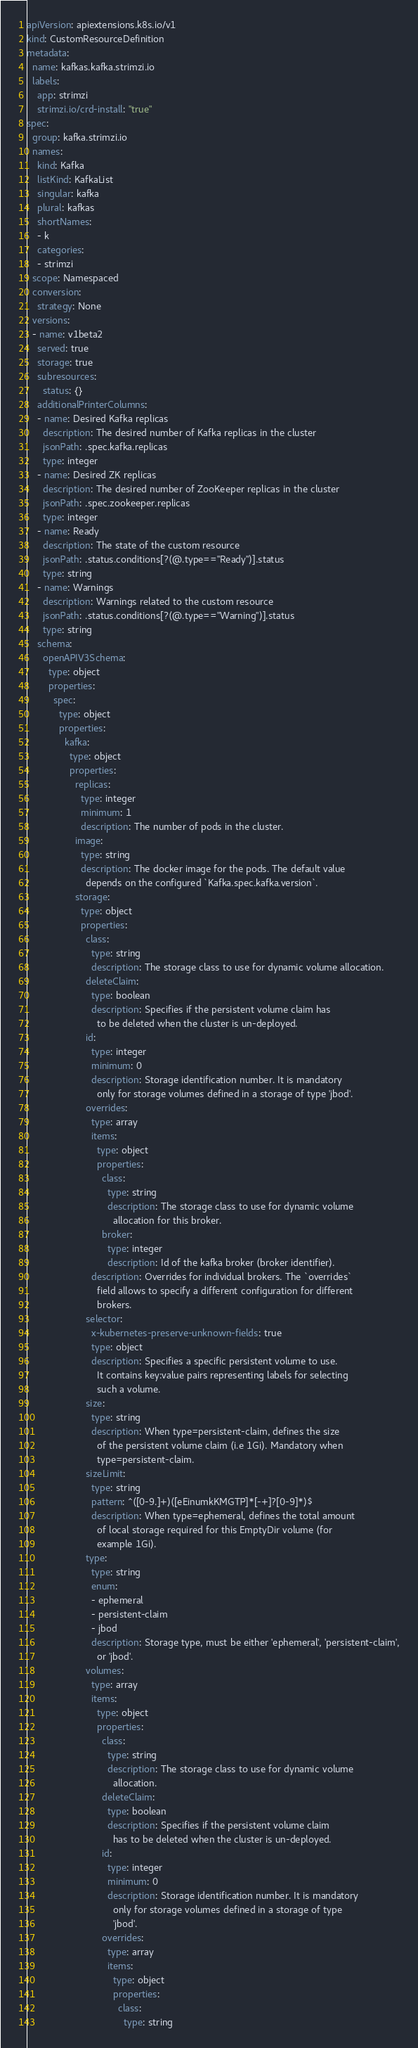Convert code to text. <code><loc_0><loc_0><loc_500><loc_500><_YAML_>apiVersion: apiextensions.k8s.io/v1
kind: CustomResourceDefinition
metadata:
  name: kafkas.kafka.strimzi.io
  labels:
    app: strimzi
    strimzi.io/crd-install: "true"
spec:
  group: kafka.strimzi.io
  names:
    kind: Kafka
    listKind: KafkaList
    singular: kafka
    plural: kafkas
    shortNames:
    - k
    categories:
    - strimzi
  scope: Namespaced
  conversion:
    strategy: None
  versions:
  - name: v1beta2
    served: true
    storage: true
    subresources:
      status: {}
    additionalPrinterColumns:
    - name: Desired Kafka replicas
      description: The desired number of Kafka replicas in the cluster
      jsonPath: .spec.kafka.replicas
      type: integer
    - name: Desired ZK replicas
      description: The desired number of ZooKeeper replicas in the cluster
      jsonPath: .spec.zookeeper.replicas
      type: integer
    - name: Ready
      description: The state of the custom resource
      jsonPath: .status.conditions[?(@.type=="Ready")].status
      type: string
    - name: Warnings
      description: Warnings related to the custom resource
      jsonPath: .status.conditions[?(@.type=="Warning")].status
      type: string
    schema:
      openAPIV3Schema:
        type: object
        properties:
          spec:
            type: object
            properties:
              kafka:
                type: object
                properties:
                  replicas:
                    type: integer
                    minimum: 1
                    description: The number of pods in the cluster.
                  image:
                    type: string
                    description: The docker image for the pods. The default value
                      depends on the configured `Kafka.spec.kafka.version`.
                  storage:
                    type: object
                    properties:
                      class:
                        type: string
                        description: The storage class to use for dynamic volume allocation.
                      deleteClaim:
                        type: boolean
                        description: Specifies if the persistent volume claim has
                          to be deleted when the cluster is un-deployed.
                      id:
                        type: integer
                        minimum: 0
                        description: Storage identification number. It is mandatory
                          only for storage volumes defined in a storage of type 'jbod'.
                      overrides:
                        type: array
                        items:
                          type: object
                          properties:
                            class:
                              type: string
                              description: The storage class to use for dynamic volume
                                allocation for this broker.
                            broker:
                              type: integer
                              description: Id of the kafka broker (broker identifier).
                        description: Overrides for individual brokers. The `overrides`
                          field allows to specify a different configuration for different
                          brokers.
                      selector:
                        x-kubernetes-preserve-unknown-fields: true
                        type: object
                        description: Specifies a specific persistent volume to use.
                          It contains key:value pairs representing labels for selecting
                          such a volume.
                      size:
                        type: string
                        description: When type=persistent-claim, defines the size
                          of the persistent volume claim (i.e 1Gi). Mandatory when
                          type=persistent-claim.
                      sizeLimit:
                        type: string
                        pattern: ^([0-9.]+)([eEinumkKMGTP]*[-+]?[0-9]*)$
                        description: When type=ephemeral, defines the total amount
                          of local storage required for this EmptyDir volume (for
                          example 1Gi).
                      type:
                        type: string
                        enum:
                        - ephemeral
                        - persistent-claim
                        - jbod
                        description: Storage type, must be either 'ephemeral', 'persistent-claim',
                          or 'jbod'.
                      volumes:
                        type: array
                        items:
                          type: object
                          properties:
                            class:
                              type: string
                              description: The storage class to use for dynamic volume
                                allocation.
                            deleteClaim:
                              type: boolean
                              description: Specifies if the persistent volume claim
                                has to be deleted when the cluster is un-deployed.
                            id:
                              type: integer
                              minimum: 0
                              description: Storage identification number. It is mandatory
                                only for storage volumes defined in a storage of type
                                'jbod'.
                            overrides:
                              type: array
                              items:
                                type: object
                                properties:
                                  class:
                                    type: string</code> 